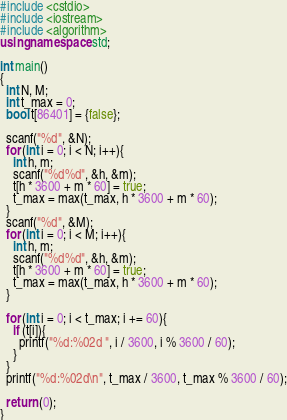<code> <loc_0><loc_0><loc_500><loc_500><_C++_>#include <cstdio>
#include <iostream>
#include <algorithm>
using namespace std;

int main()
{
  int N, M;
  int t_max = 0;
  bool t[86401] = {false};

  scanf("%d", &N);
  for (int i = 0; i < N; i++){
    int h, m;
    scanf("%d%d", &h, &m);
    t[h * 3600 + m * 60] = true;
    t_max = max(t_max, h * 3600 + m * 60);
  }
  scanf("%d", &M);
  for (int i = 0; i < M; i++){
    int h, m;
    scanf("%d%d", &h, &m);
    t[h * 3600 + m * 60] = true;
    t_max = max(t_max, h * 3600 + m * 60);
  }

  for (int i = 0; i < t_max; i += 60){
    if (t[i]){
      printf("%d:%02d ", i / 3600, i % 3600 / 60);
    }
  }
  printf("%d:%02d\n", t_max / 3600, t_max % 3600 / 60);

  return (0);
}</code> 